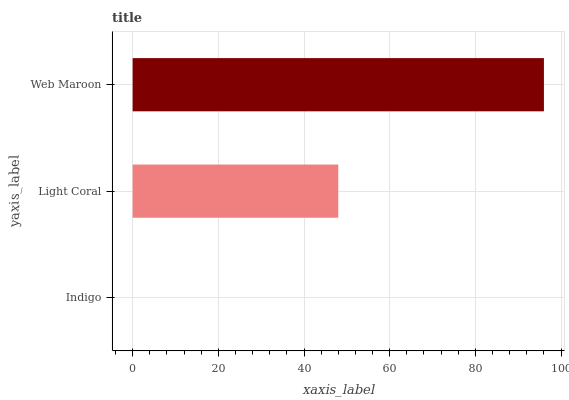Is Indigo the minimum?
Answer yes or no. Yes. Is Web Maroon the maximum?
Answer yes or no. Yes. Is Light Coral the minimum?
Answer yes or no. No. Is Light Coral the maximum?
Answer yes or no. No. Is Light Coral greater than Indigo?
Answer yes or no. Yes. Is Indigo less than Light Coral?
Answer yes or no. Yes. Is Indigo greater than Light Coral?
Answer yes or no. No. Is Light Coral less than Indigo?
Answer yes or no. No. Is Light Coral the high median?
Answer yes or no. Yes. Is Light Coral the low median?
Answer yes or no. Yes. Is Indigo the high median?
Answer yes or no. No. Is Web Maroon the low median?
Answer yes or no. No. 